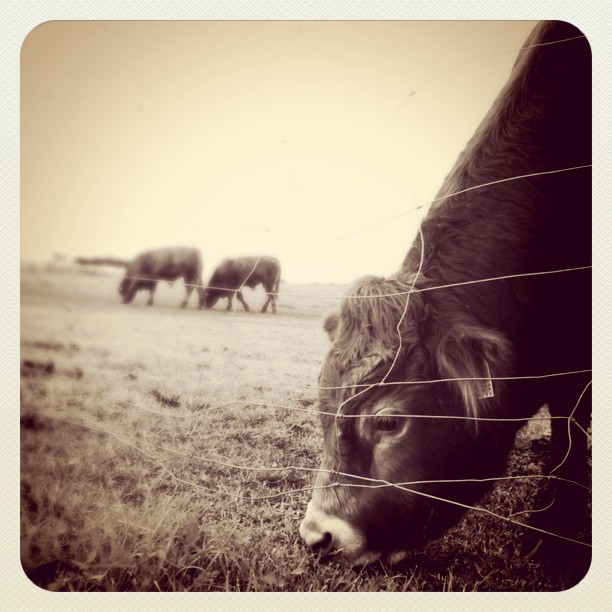How many water ski boards have yellow lights shedding on them? I'm sorry, but it seems there was a misunderstanding. The image does not depict water or ski boards but shows a rural scene with cattle. There are no yellow lights or water ski boards in this image. 